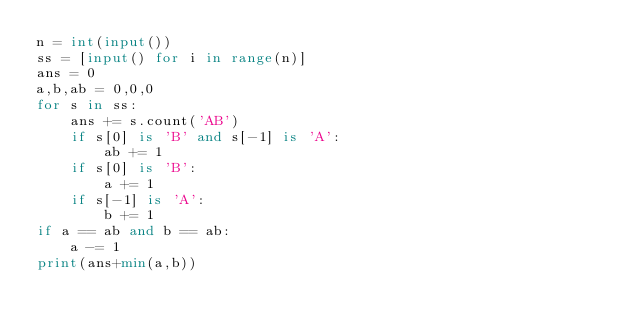<code> <loc_0><loc_0><loc_500><loc_500><_Python_>n = int(input())
ss = [input() for i in range(n)]
ans = 0
a,b,ab = 0,0,0
for s in ss:
    ans += s.count('AB')
    if s[0] is 'B' and s[-1] is 'A':
        ab += 1
    if s[0] is 'B':
        a += 1
    if s[-1] is 'A':
        b += 1
if a == ab and b == ab:
    a -= 1
print(ans+min(a,b))
</code> 